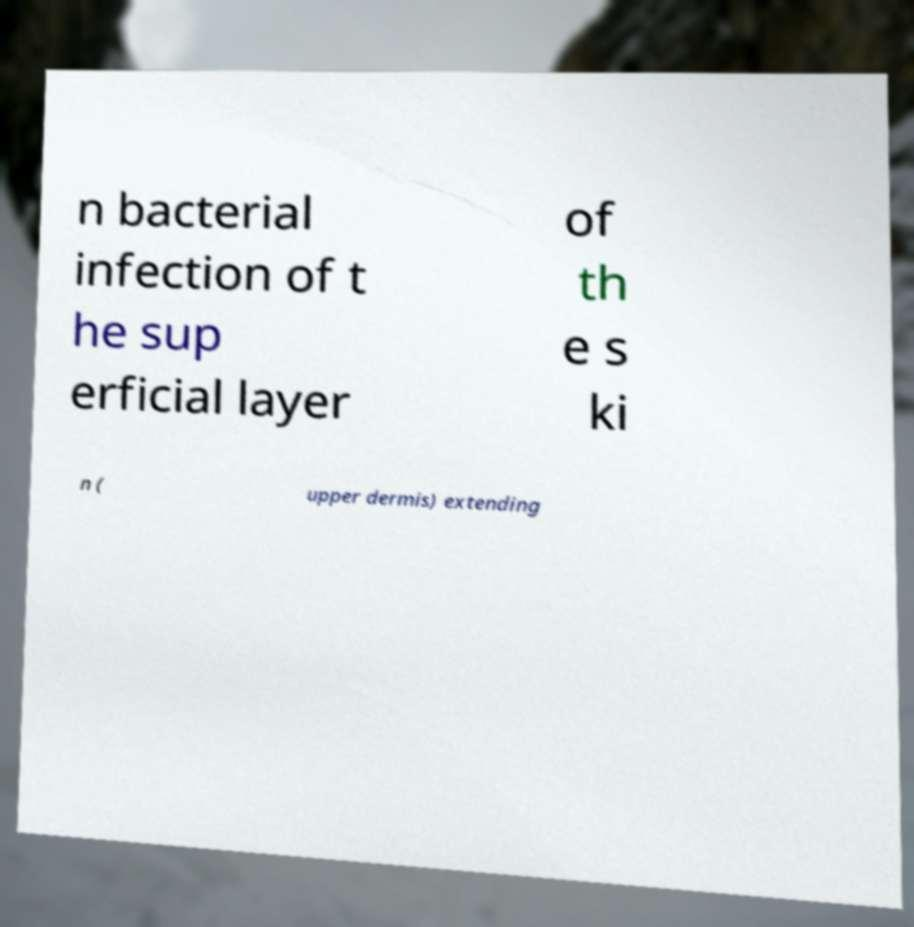Can you read and provide the text displayed in the image?This photo seems to have some interesting text. Can you extract and type it out for me? n bacterial infection of t he sup erficial layer of th e s ki n ( upper dermis) extending 